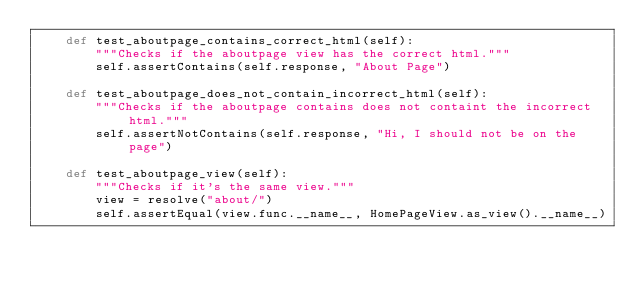<code> <loc_0><loc_0><loc_500><loc_500><_Python_>    def test_aboutpage_contains_correct_html(self):
        """Checks if the aboutpage view has the correct html."""
        self.assertContains(self.response, "About Page")

    def test_aboutpage_does_not_contain_incorrect_html(self):
        """Checks if the aboutpage contains does not containt the incorrect html."""
        self.assertNotContains(self.response, "Hi, I should not be on the page")

    def test_aboutpage_view(self):
        """Checks if it's the same view."""
        view = resolve("about/")
        self.assertEqual(view.func.__name__, HomePageView.as_view().__name__)
</code> 